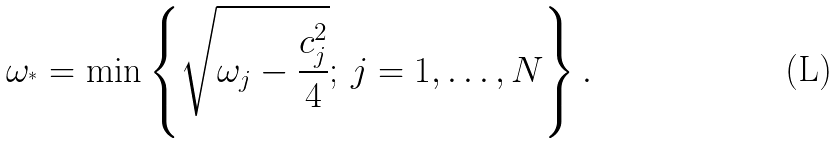<formula> <loc_0><loc_0><loc_500><loc_500>\omega _ { ^ { * } } = \min \left \{ \sqrt { \omega _ { j } - \frac { c _ { j } ^ { 2 } } { 4 } } ; \, j = 1 , \dots , N \right \} .</formula> 